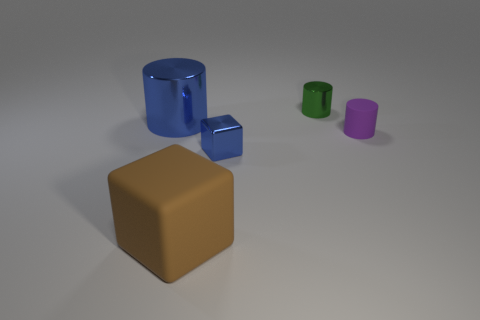What is the size of the blue shiny thing that is the same shape as the big brown object?
Provide a succinct answer. Small. How many tiny cubes are made of the same material as the big brown block?
Your response must be concise. 0. How many metal cubes are the same color as the large matte thing?
Keep it short and to the point. 0. How many objects are either small purple matte objects that are on the right side of the tiny green thing or cylinders in front of the blue cylinder?
Your response must be concise. 1. Are there fewer blocks that are behind the large metal cylinder than tiny red cubes?
Keep it short and to the point. No. Are there any cylinders of the same size as the green metallic object?
Your answer should be very brief. Yes. The large matte object is what color?
Provide a succinct answer. Brown. Do the purple cylinder and the green shiny object have the same size?
Keep it short and to the point. Yes. How many things are either tiny blue metal blocks or big blue metallic cylinders?
Your answer should be compact. 2. Are there an equal number of big things right of the tiny green metallic cylinder and small yellow cubes?
Your answer should be very brief. Yes. 